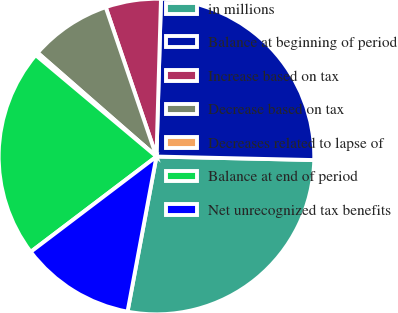Convert chart to OTSL. <chart><loc_0><loc_0><loc_500><loc_500><pie_chart><fcel>in millions<fcel>Balance at beginning of period<fcel>Increase based on tax<fcel>Decrease based on tax<fcel>Decreases related to lapse of<fcel>Balance at end of period<fcel>Net unrecognized tax benefits<nl><fcel>27.58%<fcel>24.9%<fcel>5.67%<fcel>8.36%<fcel>0.31%<fcel>21.44%<fcel>11.74%<nl></chart> 